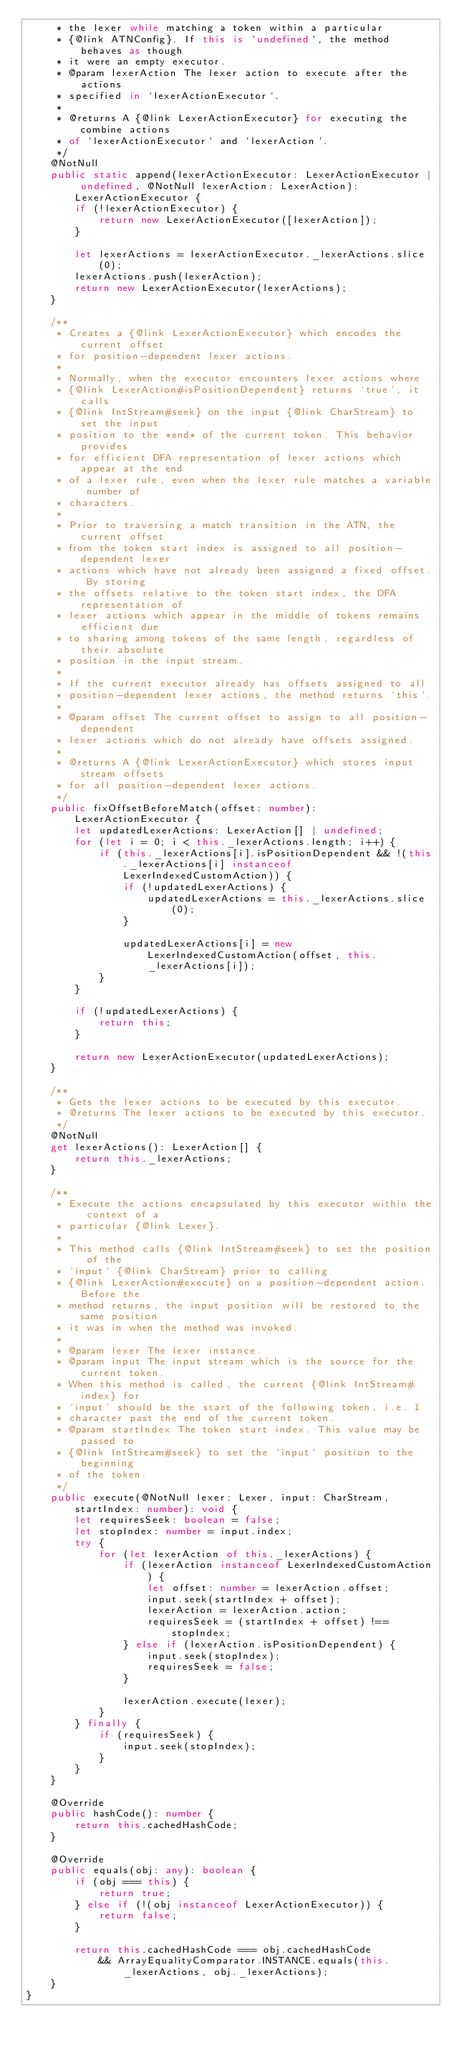<code> <loc_0><loc_0><loc_500><loc_500><_TypeScript_>	 * the lexer while matching a token within a particular
	 * {@link ATNConfig}. If this is `undefined`, the method behaves as though
	 * it were an empty executor.
	 * @param lexerAction The lexer action to execute after the actions
	 * specified in `lexerActionExecutor`.
	 *
	 * @returns A {@link LexerActionExecutor} for executing the combine actions
	 * of `lexerActionExecutor` and `lexerAction`.
	 */
	@NotNull
	public static append(lexerActionExecutor: LexerActionExecutor | undefined, @NotNull lexerAction: LexerAction): LexerActionExecutor {
		if (!lexerActionExecutor) {
			return new LexerActionExecutor([lexerAction]);
		}

		let lexerActions = lexerActionExecutor._lexerActions.slice(0);
		lexerActions.push(lexerAction);
		return new LexerActionExecutor(lexerActions);
	}

	/**
	 * Creates a {@link LexerActionExecutor} which encodes the current offset
	 * for position-dependent lexer actions.
	 *
	 * Normally, when the executor encounters lexer actions where
	 * {@link LexerAction#isPositionDependent} returns `true`, it calls
	 * {@link IntStream#seek} on the input {@link CharStream} to set the input
	 * position to the *end* of the current token. This behavior provides
	 * for efficient DFA representation of lexer actions which appear at the end
	 * of a lexer rule, even when the lexer rule matches a variable number of
	 * characters.
	 *
	 * Prior to traversing a match transition in the ATN, the current offset
	 * from the token start index is assigned to all position-dependent lexer
	 * actions which have not already been assigned a fixed offset. By storing
	 * the offsets relative to the token start index, the DFA representation of
	 * lexer actions which appear in the middle of tokens remains efficient due
	 * to sharing among tokens of the same length, regardless of their absolute
	 * position in the input stream.
	 *
	 * If the current executor already has offsets assigned to all
	 * position-dependent lexer actions, the method returns `this`.
	 *
	 * @param offset The current offset to assign to all position-dependent
	 * lexer actions which do not already have offsets assigned.
	 *
	 * @returns A {@link LexerActionExecutor} which stores input stream offsets
	 * for all position-dependent lexer actions.
	 */
	public fixOffsetBeforeMatch(offset: number): LexerActionExecutor {
		let updatedLexerActions: LexerAction[] | undefined;
		for (let i = 0; i < this._lexerActions.length; i++) {
			if (this._lexerActions[i].isPositionDependent && !(this._lexerActions[i] instanceof LexerIndexedCustomAction)) {
				if (!updatedLexerActions) {
					updatedLexerActions = this._lexerActions.slice(0);
				}

				updatedLexerActions[i] = new LexerIndexedCustomAction(offset, this._lexerActions[i]);
			}
		}

		if (!updatedLexerActions) {
			return this;
		}

		return new LexerActionExecutor(updatedLexerActions);
	}

	/**
	 * Gets the lexer actions to be executed by this executor.
	 * @returns The lexer actions to be executed by this executor.
	 */
	@NotNull
	get lexerActions(): LexerAction[] {
		return this._lexerActions;
	}

	/**
	 * Execute the actions encapsulated by this executor within the context of a
	 * particular {@link Lexer}.
	 *
	 * This method calls {@link IntStream#seek} to set the position of the
	 * `input` {@link CharStream} prior to calling
	 * {@link LexerAction#execute} on a position-dependent action. Before the
	 * method returns, the input position will be restored to the same position
	 * it was in when the method was invoked.
	 *
	 * @param lexer The lexer instance.
	 * @param input The input stream which is the source for the current token.
	 * When this method is called, the current {@link IntStream#index} for
	 * `input` should be the start of the following token, i.e. 1
	 * character past the end of the current token.
	 * @param startIndex The token start index. This value may be passed to
	 * {@link IntStream#seek} to set the `input` position to the beginning
	 * of the token.
	 */
	public execute(@NotNull lexer: Lexer, input: CharStream, startIndex: number): void {
		let requiresSeek: boolean = false;
		let stopIndex: number = input.index;
		try {
			for (let lexerAction of this._lexerActions) {
				if (lexerAction instanceof LexerIndexedCustomAction) {
					let offset: number = lexerAction.offset;
					input.seek(startIndex + offset);
					lexerAction = lexerAction.action;
					requiresSeek = (startIndex + offset) !== stopIndex;
				} else if (lexerAction.isPositionDependent) {
					input.seek(stopIndex);
					requiresSeek = false;
				}

				lexerAction.execute(lexer);
			}
		} finally {
			if (requiresSeek) {
				input.seek(stopIndex);
			}
		}
	}

	@Override
	public hashCode(): number {
		return this.cachedHashCode;
	}

	@Override
	public equals(obj: any): boolean {
		if (obj === this) {
			return true;
		} else if (!(obj instanceof LexerActionExecutor)) {
			return false;
		}

		return this.cachedHashCode === obj.cachedHashCode
			&& ArrayEqualityComparator.INSTANCE.equals(this._lexerActions, obj._lexerActions);
	}
}
</code> 